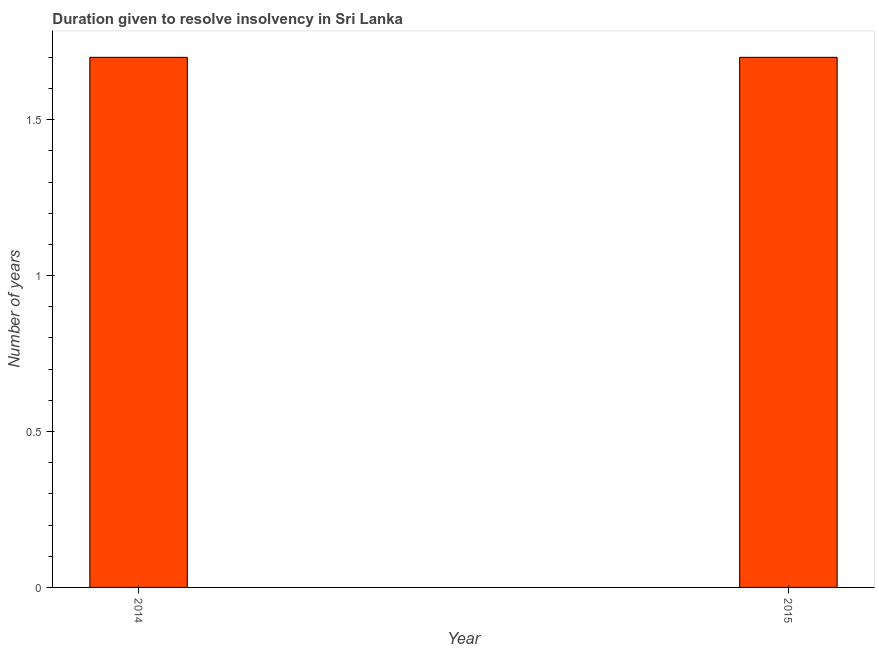Does the graph contain any zero values?
Your answer should be compact. No. Does the graph contain grids?
Make the answer very short. No. What is the title of the graph?
Make the answer very short. Duration given to resolve insolvency in Sri Lanka. What is the label or title of the X-axis?
Offer a terse response. Year. What is the label or title of the Y-axis?
Your response must be concise. Number of years. What is the number of years to resolve insolvency in 2015?
Offer a very short reply. 1.7. Across all years, what is the minimum number of years to resolve insolvency?
Keep it short and to the point. 1.7. What is the sum of the number of years to resolve insolvency?
Your answer should be very brief. 3.4. What is the difference between the number of years to resolve insolvency in 2014 and 2015?
Offer a very short reply. 0. Is the number of years to resolve insolvency in 2014 less than that in 2015?
Your answer should be compact. No. How many bars are there?
Your answer should be compact. 2. Are all the bars in the graph horizontal?
Your response must be concise. No. How many years are there in the graph?
Offer a terse response. 2. Are the values on the major ticks of Y-axis written in scientific E-notation?
Your response must be concise. No. What is the Number of years in 2014?
Provide a short and direct response. 1.7. What is the ratio of the Number of years in 2014 to that in 2015?
Ensure brevity in your answer.  1. 